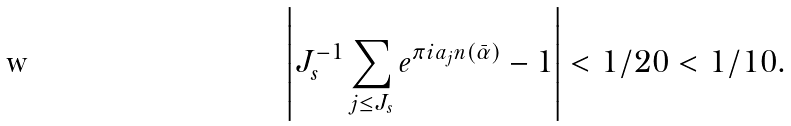<formula> <loc_0><loc_0><loc_500><loc_500>\left | J _ { s } ^ { - 1 } \sum _ { j \leq J _ { s } } e ^ { \pi i a _ { j } n ( \bar { \alpha } ) } - 1 \right | < 1 / 2 0 < 1 / 1 0 .</formula> 